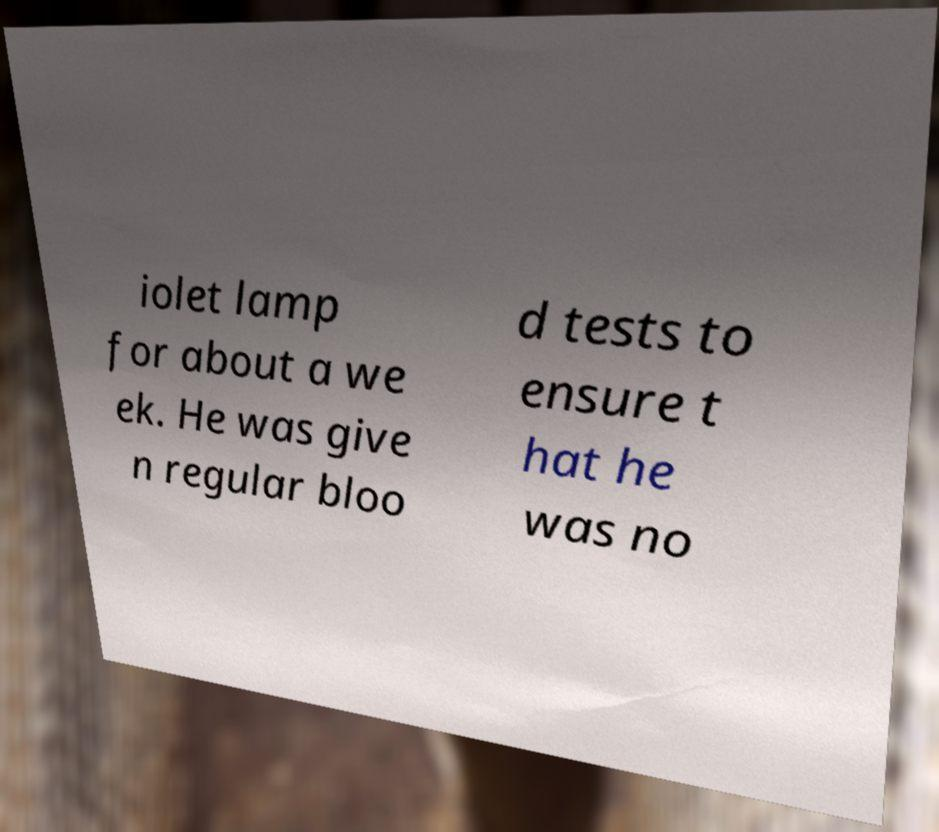Could you assist in decoding the text presented in this image and type it out clearly? iolet lamp for about a we ek. He was give n regular bloo d tests to ensure t hat he was no 